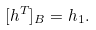Convert formula to latex. <formula><loc_0><loc_0><loc_500><loc_500>[ h ^ { T } ] _ { B } = h _ { 1 } .</formula> 